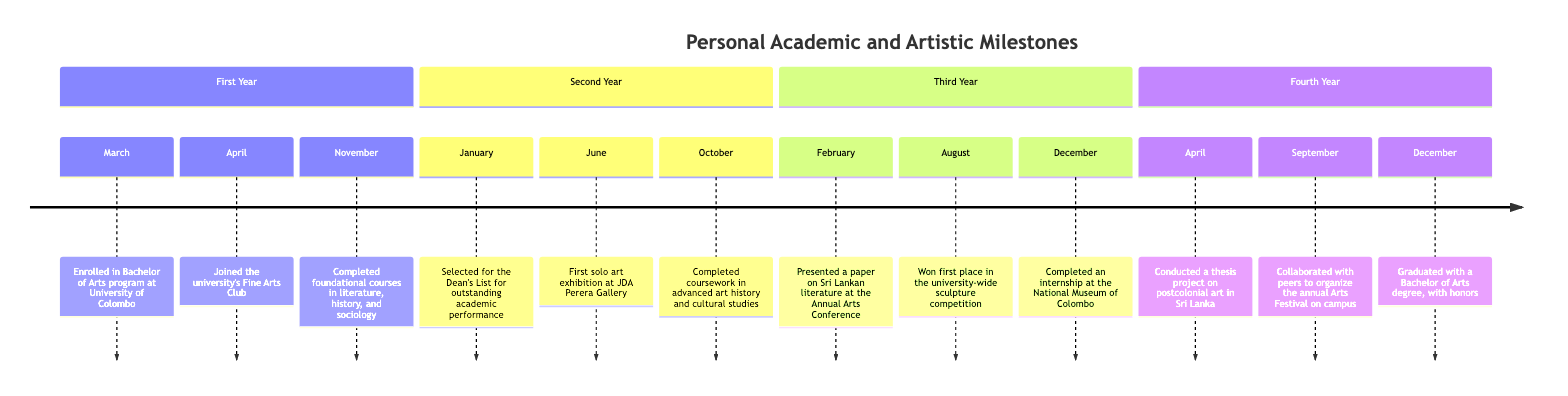What is the first milestone listed in the timeline? The first milestone in the timeline is "Enrolled in Bachelor of Arts program at University of Colombo," which occurs in March of the First Year.
Answer: Enrolled in Bachelor of Arts program at University of Colombo How many artistic milestones are recorded in the timeline? By counting the artistic milestones listed: First Year has 1, Second Year has 1, Third Year has 1, and Fourth Year has 1, resulting in a total of 4 artistic milestones.
Answer: 4 In which month did the graduation take place? The graduation occurred in December of the Fourth Year, as indicated by the milestone "Graduated with a Bachelor of Arts degree, with honors."
Answer: December What was the focus of the thesis project conducted in the Fourth Year? The thesis project focus was "postcolonial art in Sri Lanka," as specified in the milestone listed for the Fourth Year in April.
Answer: postcolonial art in Sri Lanka Which year saw the first solo art exhibition? The first solo art exhibition occurred in the Second Year, specifically in June, as described in the milestone for that year.
Answer: Second Year What is the relationship between being selected for the Dean's List and academic performance? Being selected for the Dean's List represents outstanding academic performance, as explained in the milestone for January of the Second Year.
Answer: outstanding academic performance How many total milestones are recorded across all four years? There are a total of 12 milestones listed in the timeline: 3 from each year (First Year, Second Year, Third Year, and Fourth Year).
Answer: 12 What is unique about the milestone in February of the Third Year? The February milestone in the Third Year is unique because it involves presenting a paper, specifically on Sri Lankan literature, at a conference, which reflects academic engagement beyond regular coursework.
Answer: Presented a paper on Sri Lankan literature at the Annual Arts Conference In which year did the collaborative organization of the annual Arts Festival occur? The milestone indicating the collaboration to organize the annual Arts Festival is in the Fourth Year, specifically in September, as noted in the timeline.
Answer: Fourth Year 